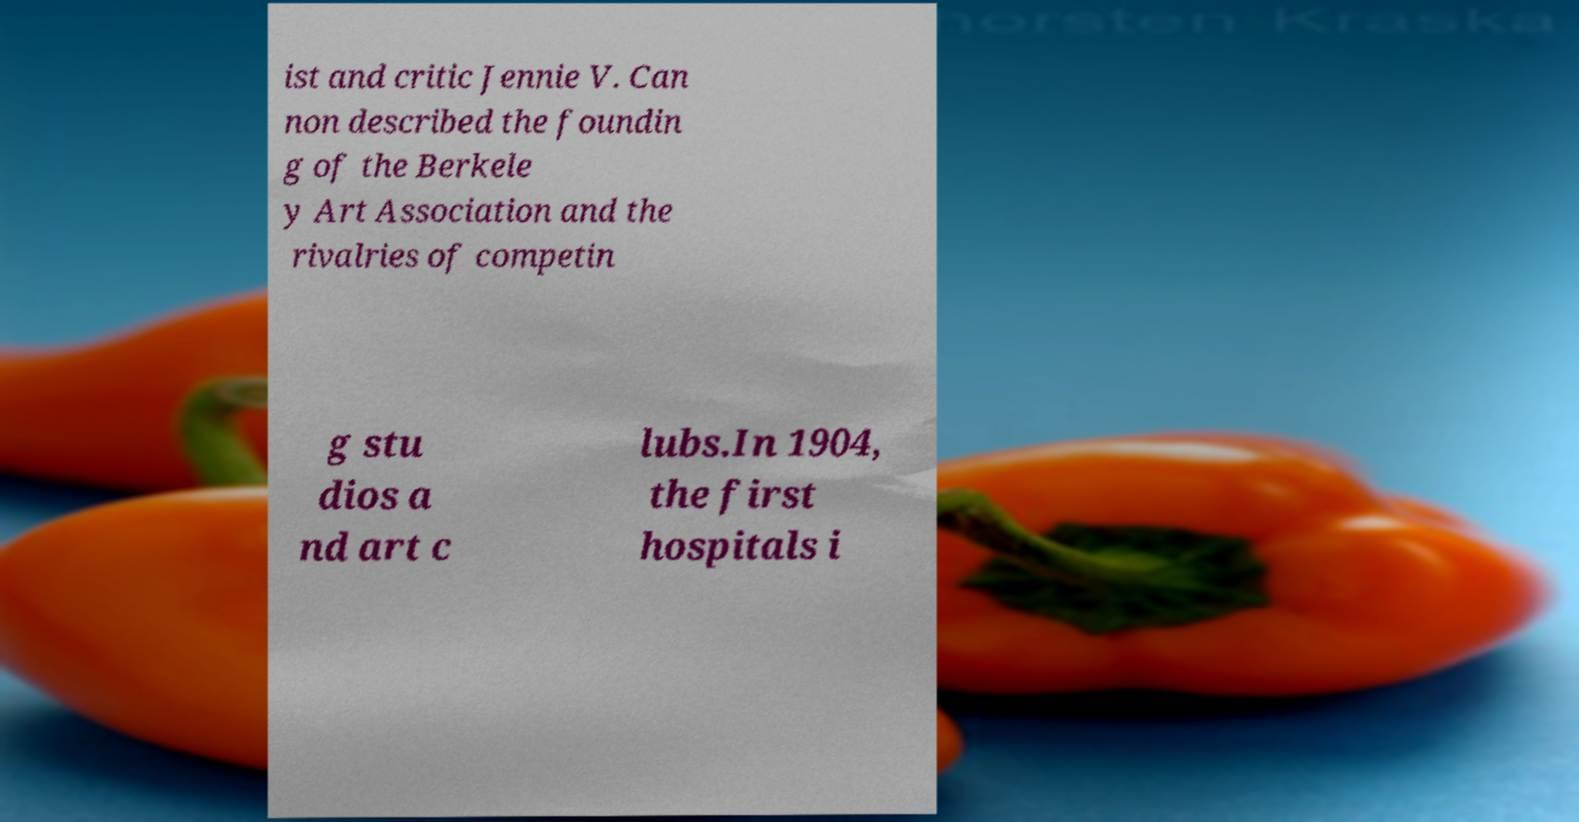There's text embedded in this image that I need extracted. Can you transcribe it verbatim? ist and critic Jennie V. Can non described the foundin g of the Berkele y Art Association and the rivalries of competin g stu dios a nd art c lubs.In 1904, the first hospitals i 